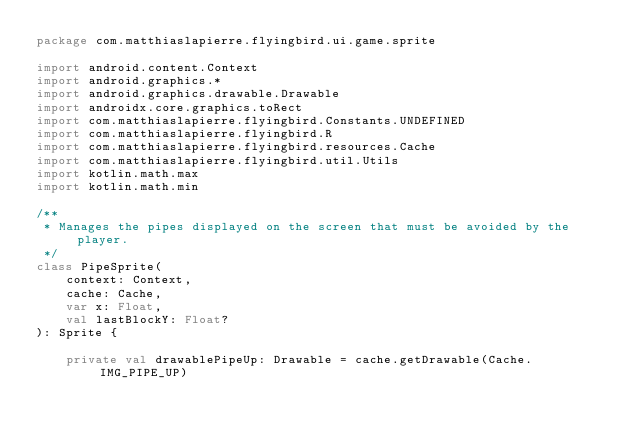<code> <loc_0><loc_0><loc_500><loc_500><_Kotlin_>package com.matthiaslapierre.flyingbird.ui.game.sprite

import android.content.Context
import android.graphics.*
import android.graphics.drawable.Drawable
import androidx.core.graphics.toRect
import com.matthiaslapierre.flyingbird.Constants.UNDEFINED
import com.matthiaslapierre.flyingbird.R
import com.matthiaslapierre.flyingbird.resources.Cache
import com.matthiaslapierre.flyingbird.util.Utils
import kotlin.math.max
import kotlin.math.min

/**
 * Manages the pipes displayed on the screen that must be avoided by the player.
 */
class PipeSprite(
    context: Context,
    cache: Cache,
    var x: Float,
    val lastBlockY: Float?
): Sprite {

    private val drawablePipeUp: Drawable = cache.getDrawable(Cache.IMG_PIPE_UP)</code> 